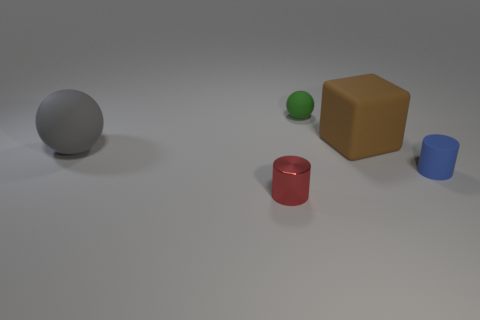Can you name the shapes and colors of the objects in this image starting from the left? Sure. Starting from the left, we have a large grey sphere, a small green sphere, a big brown cube, a medium-sized red cylinder, and a small blue cylinder. 